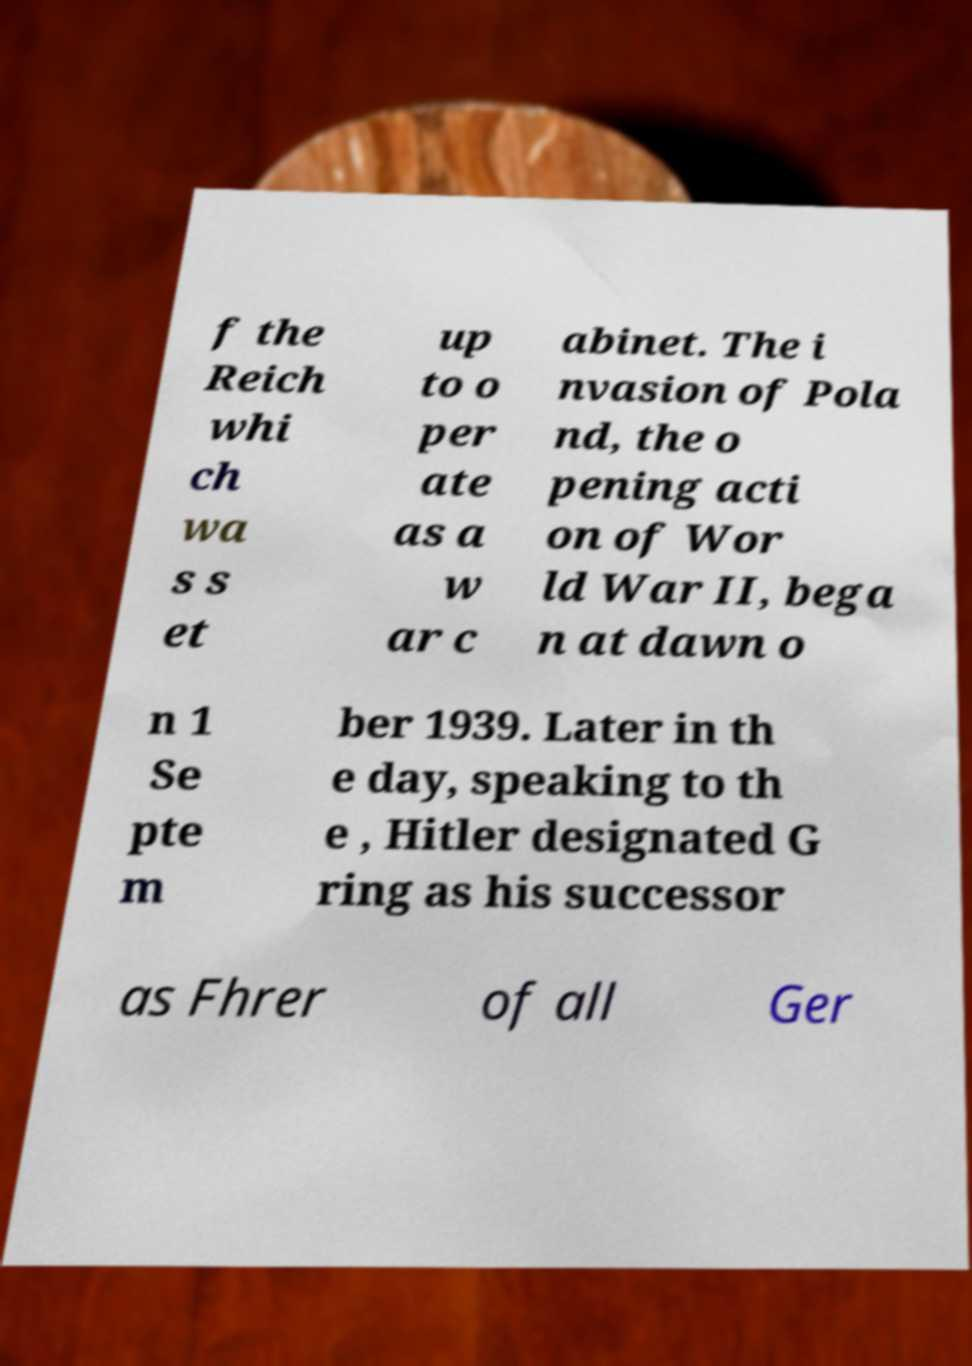There's text embedded in this image that I need extracted. Can you transcribe it verbatim? f the Reich whi ch wa s s et up to o per ate as a w ar c abinet. The i nvasion of Pola nd, the o pening acti on of Wor ld War II, bega n at dawn o n 1 Se pte m ber 1939. Later in th e day, speaking to th e , Hitler designated G ring as his successor as Fhrer of all Ger 